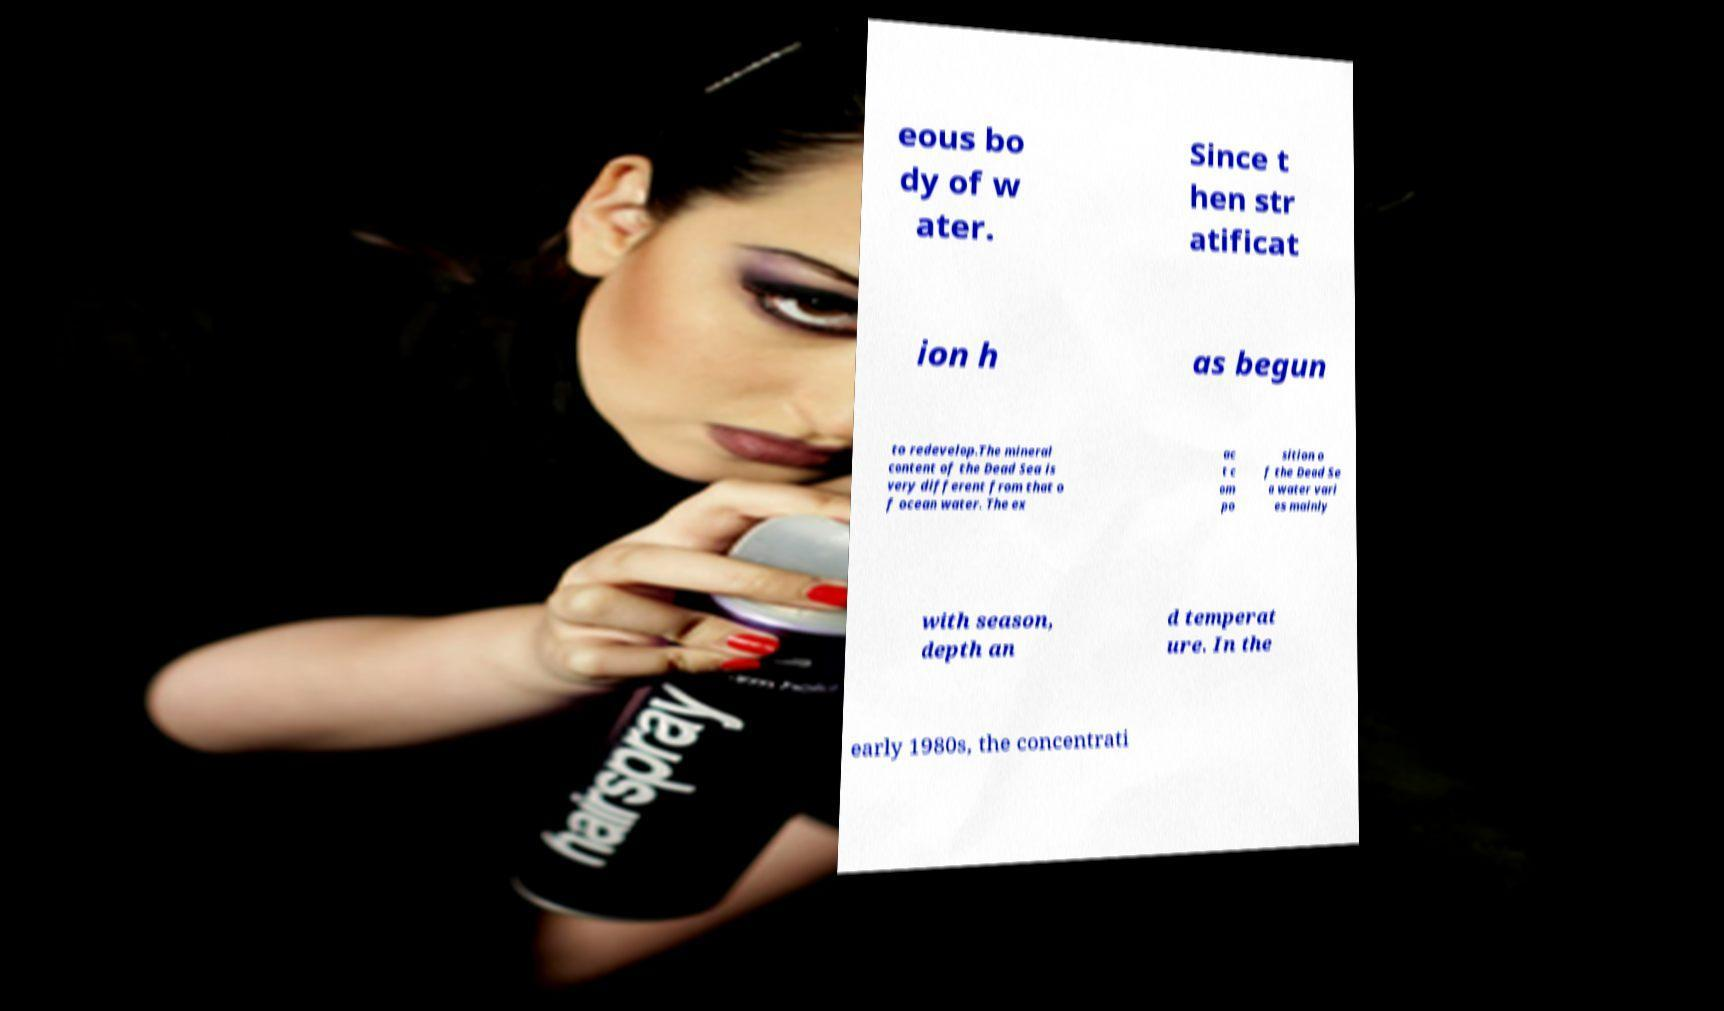Please identify and transcribe the text found in this image. eous bo dy of w ater. Since t hen str atificat ion h as begun to redevelop.The mineral content of the Dead Sea is very different from that o f ocean water. The ex ac t c om po sition o f the Dead Se a water vari es mainly with season, depth an d temperat ure. In the early 1980s, the concentrati 